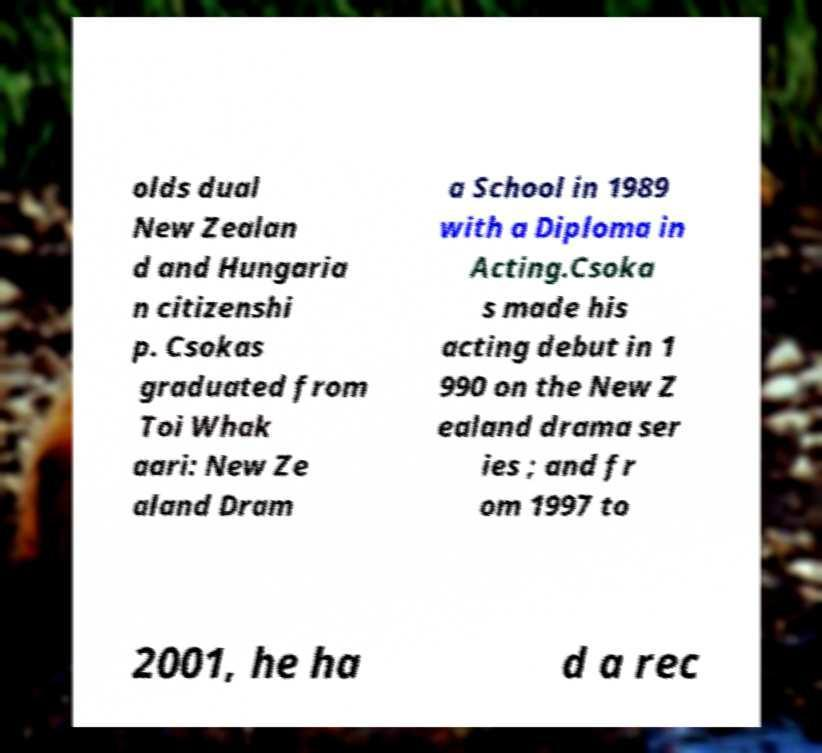Can you read and provide the text displayed in the image?This photo seems to have some interesting text. Can you extract and type it out for me? olds dual New Zealan d and Hungaria n citizenshi p. Csokas graduated from Toi Whak aari: New Ze aland Dram a School in 1989 with a Diploma in Acting.Csoka s made his acting debut in 1 990 on the New Z ealand drama ser ies ; and fr om 1997 to 2001, he ha d a rec 